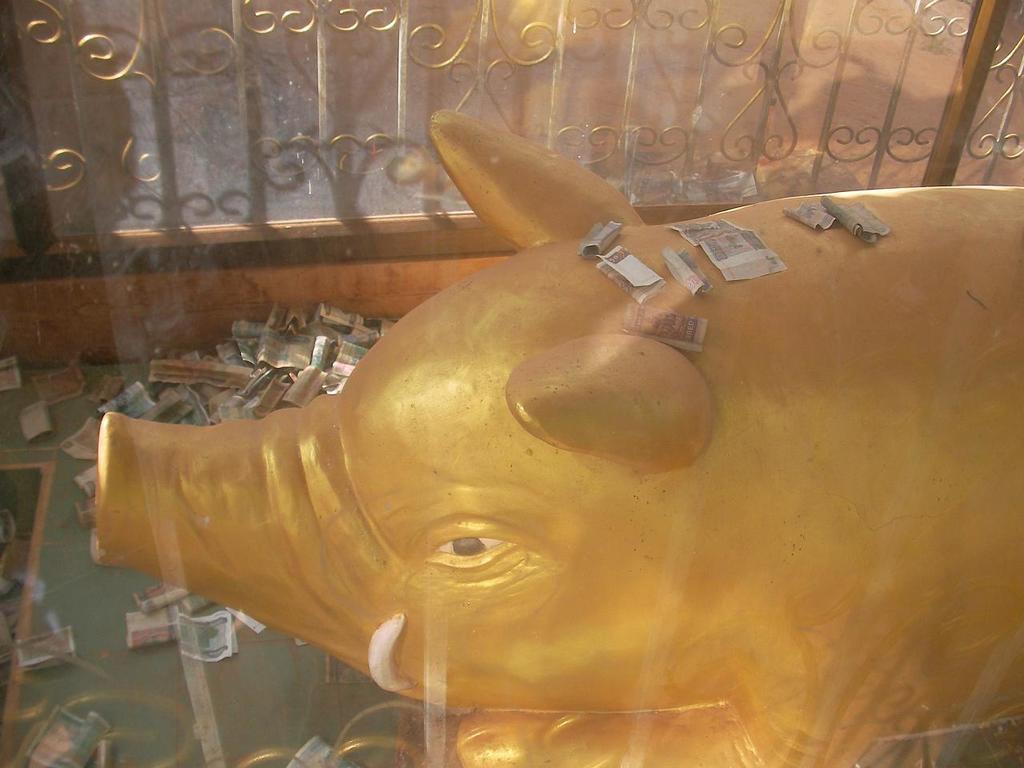Could you give a brief overview of what you see in this image? In this image I can see animal sculpture, around that there are some currency notes, beside that there is a fence. 